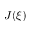<formula> <loc_0><loc_0><loc_500><loc_500>J ( \xi )</formula> 